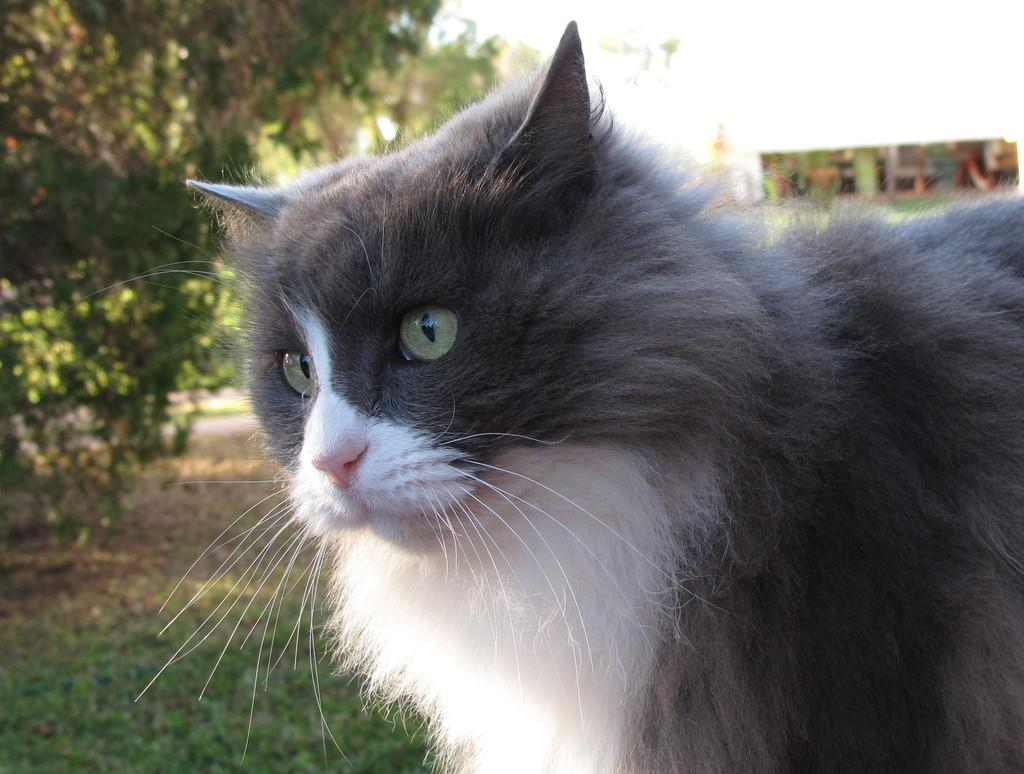What type of animal is in the image? There is a cat in the image. What type of terrain is visible at the bottom of the image? There is grassland at the bottom of the image. Where is the tree located in the image? There is a tree in the top left corner of the image. What is the fastest route for the cat to reach the tree in the image? The image does not provide information about the cat's movement or the distance between the cat and the tree, so it is not possible to determine the fastest route. 